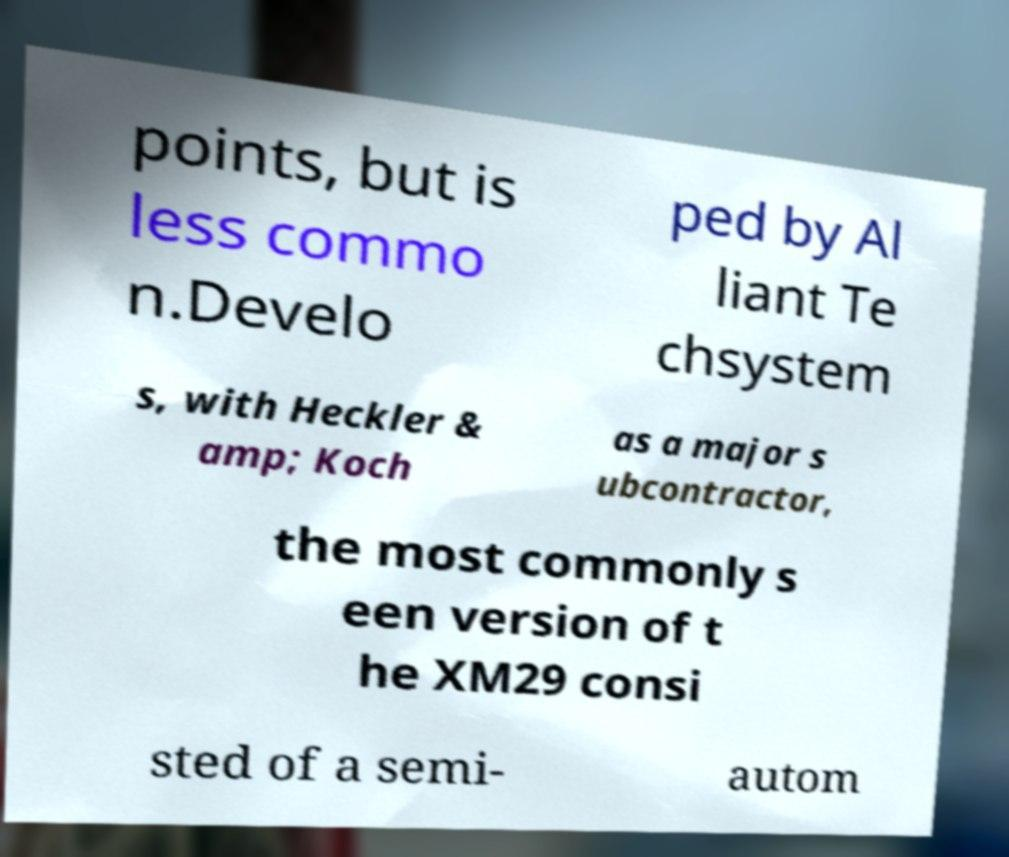Could you assist in decoding the text presented in this image and type it out clearly? points, but is less commo n.Develo ped by Al liant Te chsystem s, with Heckler & amp; Koch as a major s ubcontractor, the most commonly s een version of t he XM29 consi sted of a semi- autom 